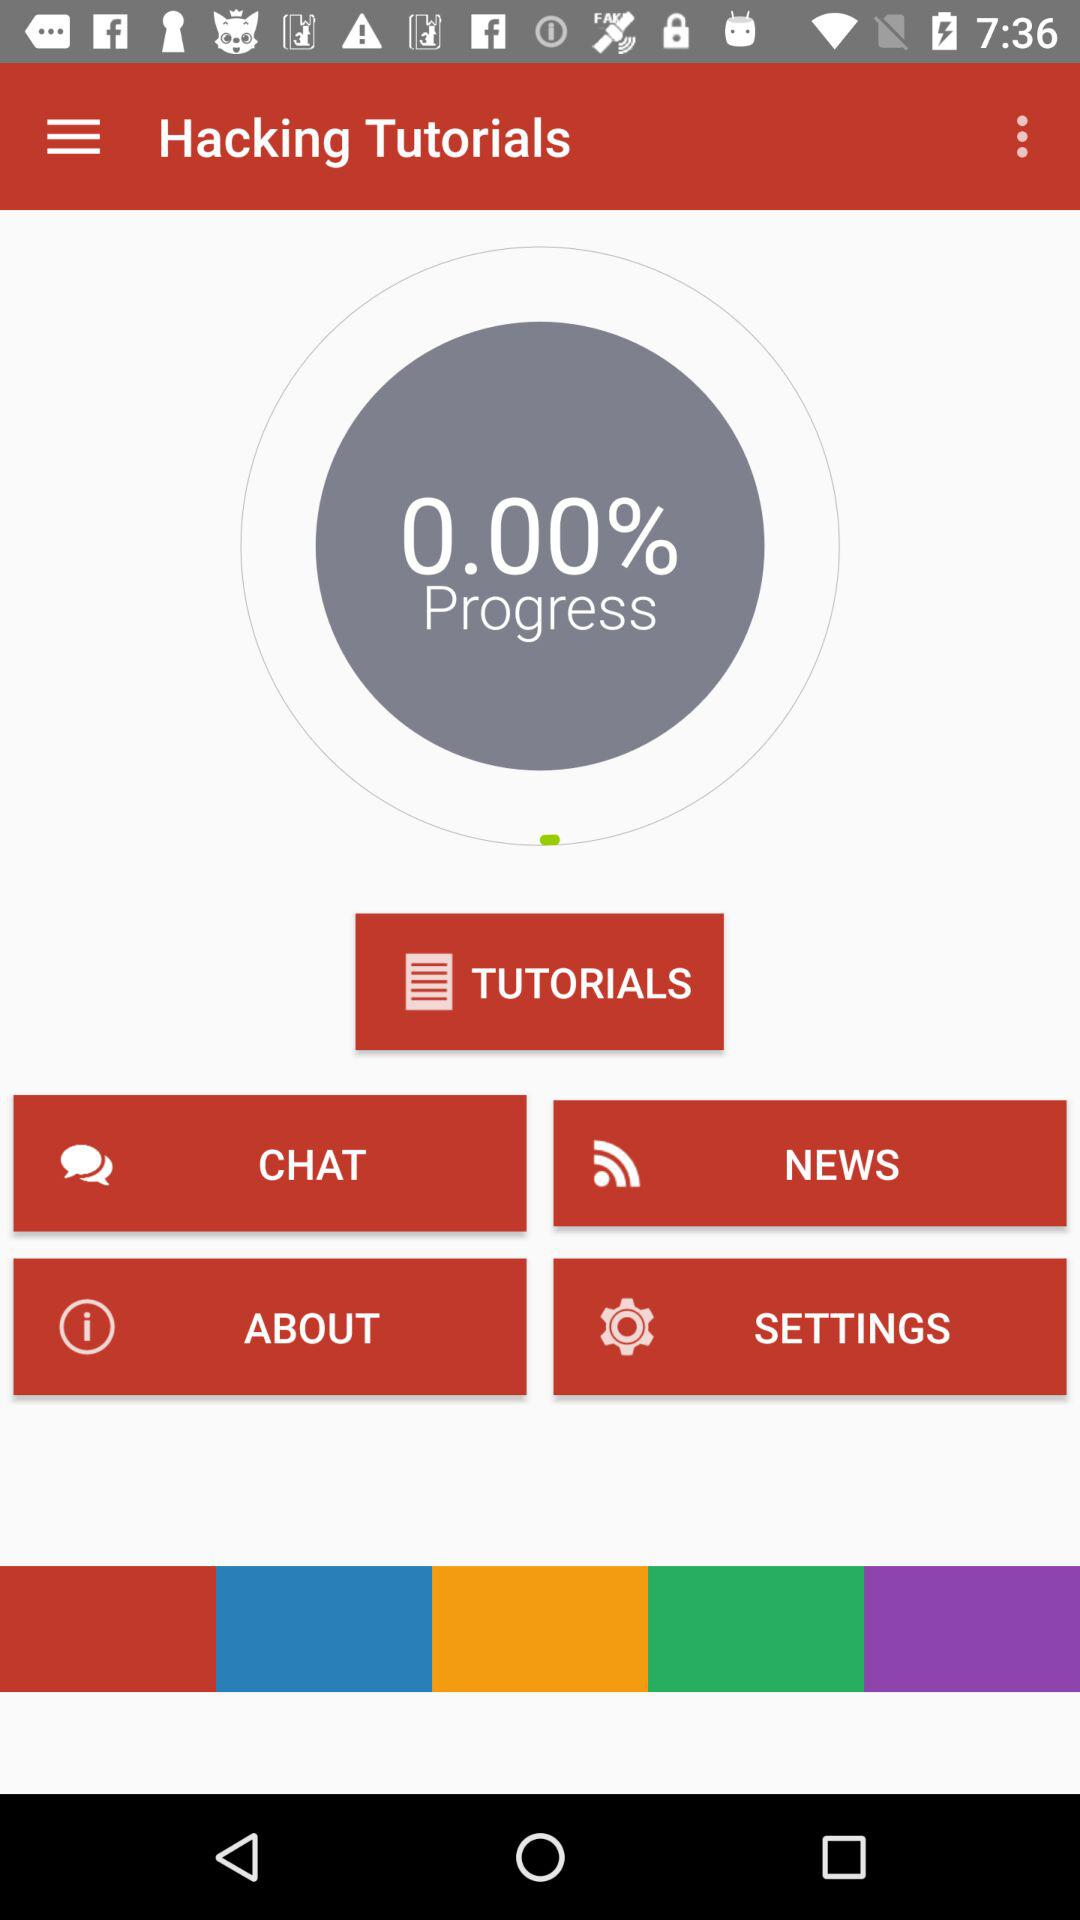What is the percentage of tutorial progress? The percentage of tutorial progress is 0.00%. 